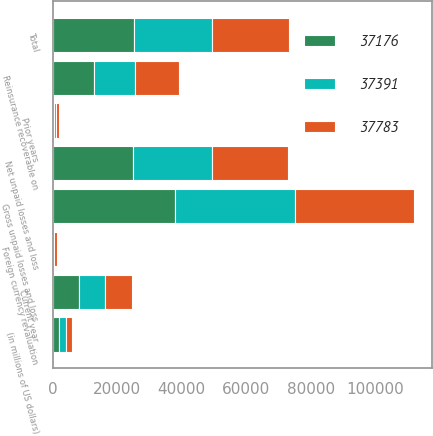Convert chart. <chart><loc_0><loc_0><loc_500><loc_500><stacked_bar_chart><ecel><fcel>(in millions of US dollars)<fcel>Gross unpaid losses and loss<fcel>Reinsurance recoverable on<fcel>Net unpaid losses and loss<fcel>Total<fcel>Current year<fcel>Prior years<fcel>Foreign currency revaluation<nl><fcel>37176<fcel>2010<fcel>37783<fcel>12745<fcel>25038<fcel>25183<fcel>8091<fcel>512<fcel>107<nl><fcel>37391<fcel>2009<fcel>37176<fcel>12935<fcel>24241<fcel>24241<fcel>8001<fcel>579<fcel>323<nl><fcel>37783<fcel>2008<fcel>37112<fcel>13520<fcel>23592<fcel>23945<fcel>8417<fcel>814<fcel>980<nl></chart> 